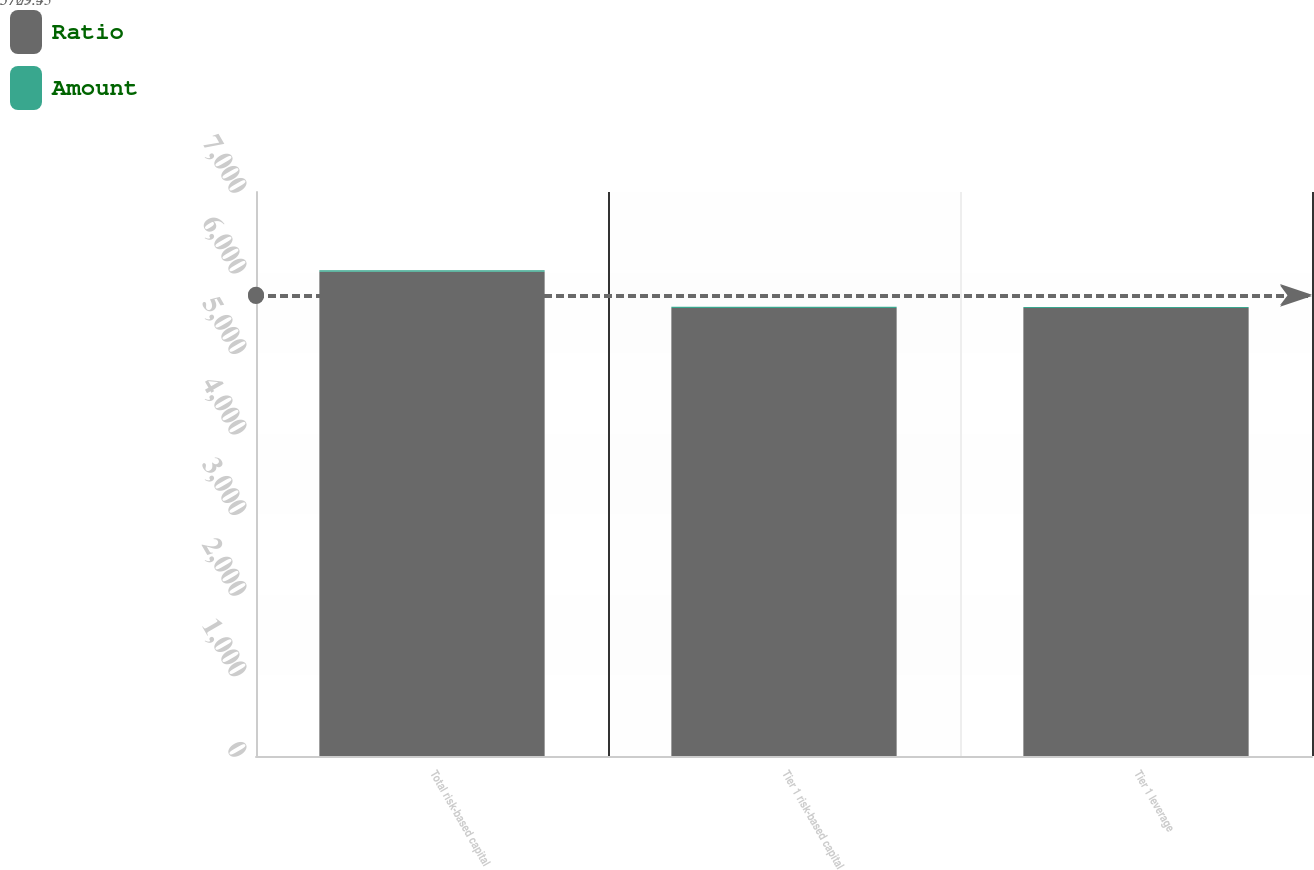Convert chart to OTSL. <chart><loc_0><loc_0><loc_500><loc_500><stacked_bar_chart><ecel><fcel>Total risk-based capital<fcel>Tier 1 risk-based capital<fcel>Tier 1 leverage<nl><fcel>Ratio<fcel>6010<fcel>5559<fcel>5559<nl><fcel>Amount<fcel>17.3<fcel>16<fcel>14.9<nl></chart> 